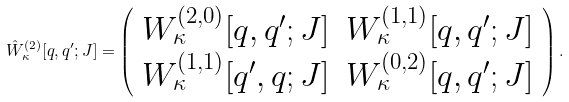Convert formula to latex. <formula><loc_0><loc_0><loc_500><loc_500>\hat { W } ^ { ( 2 ) } _ { \kappa } [ { q } , { q ^ { \prime } } ; J ] = \left ( \begin{array} { l l } W ^ { ( 2 , 0 ) } _ { \kappa } [ { q } , { q ^ { \prime } } ; J ] & W ^ { ( 1 , 1 ) } _ { \kappa } [ { q } , { q ^ { \prime } } ; J ] \\ W ^ { ( 1 , 1 ) } _ { \kappa } [ { q ^ { \prime } } , { q } ; J ] & W ^ { ( 0 , 2 ) } _ { \kappa } [ { q } , { q ^ { \prime } } ; J ] \end{array} \right ) .</formula> 